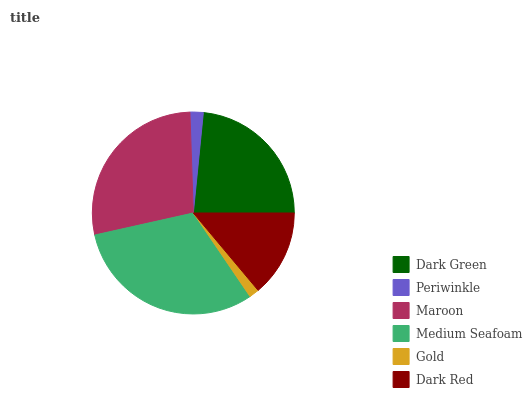Is Gold the minimum?
Answer yes or no. Yes. Is Medium Seafoam the maximum?
Answer yes or no. Yes. Is Periwinkle the minimum?
Answer yes or no. No. Is Periwinkle the maximum?
Answer yes or no. No. Is Dark Green greater than Periwinkle?
Answer yes or no. Yes. Is Periwinkle less than Dark Green?
Answer yes or no. Yes. Is Periwinkle greater than Dark Green?
Answer yes or no. No. Is Dark Green less than Periwinkle?
Answer yes or no. No. Is Dark Green the high median?
Answer yes or no. Yes. Is Dark Red the low median?
Answer yes or no. Yes. Is Maroon the high median?
Answer yes or no. No. Is Gold the low median?
Answer yes or no. No. 